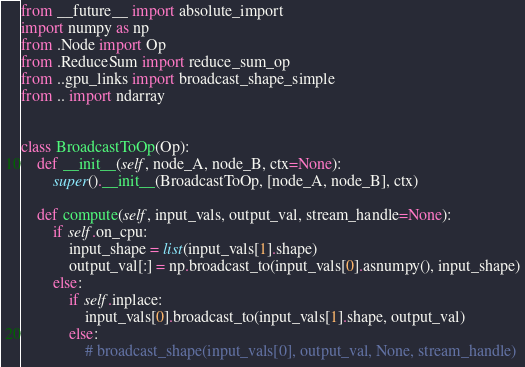Convert code to text. <code><loc_0><loc_0><loc_500><loc_500><_Python_>from __future__ import absolute_import
import numpy as np
from .Node import Op
from .ReduceSum import reduce_sum_op
from ..gpu_links import broadcast_shape_simple
from .. import ndarray


class BroadcastToOp(Op):
    def __init__(self, node_A, node_B, ctx=None):
        super().__init__(BroadcastToOp, [node_A, node_B], ctx)

    def compute(self, input_vals, output_val, stream_handle=None):
        if self.on_cpu:
            input_shape = list(input_vals[1].shape)
            output_val[:] = np.broadcast_to(input_vals[0].asnumpy(), input_shape)
        else:
            if self.inplace:
                input_vals[0].broadcast_to(input_vals[1].shape, output_val)
            else:
                # broadcast_shape(input_vals[0], output_val, None, stream_handle)</code> 